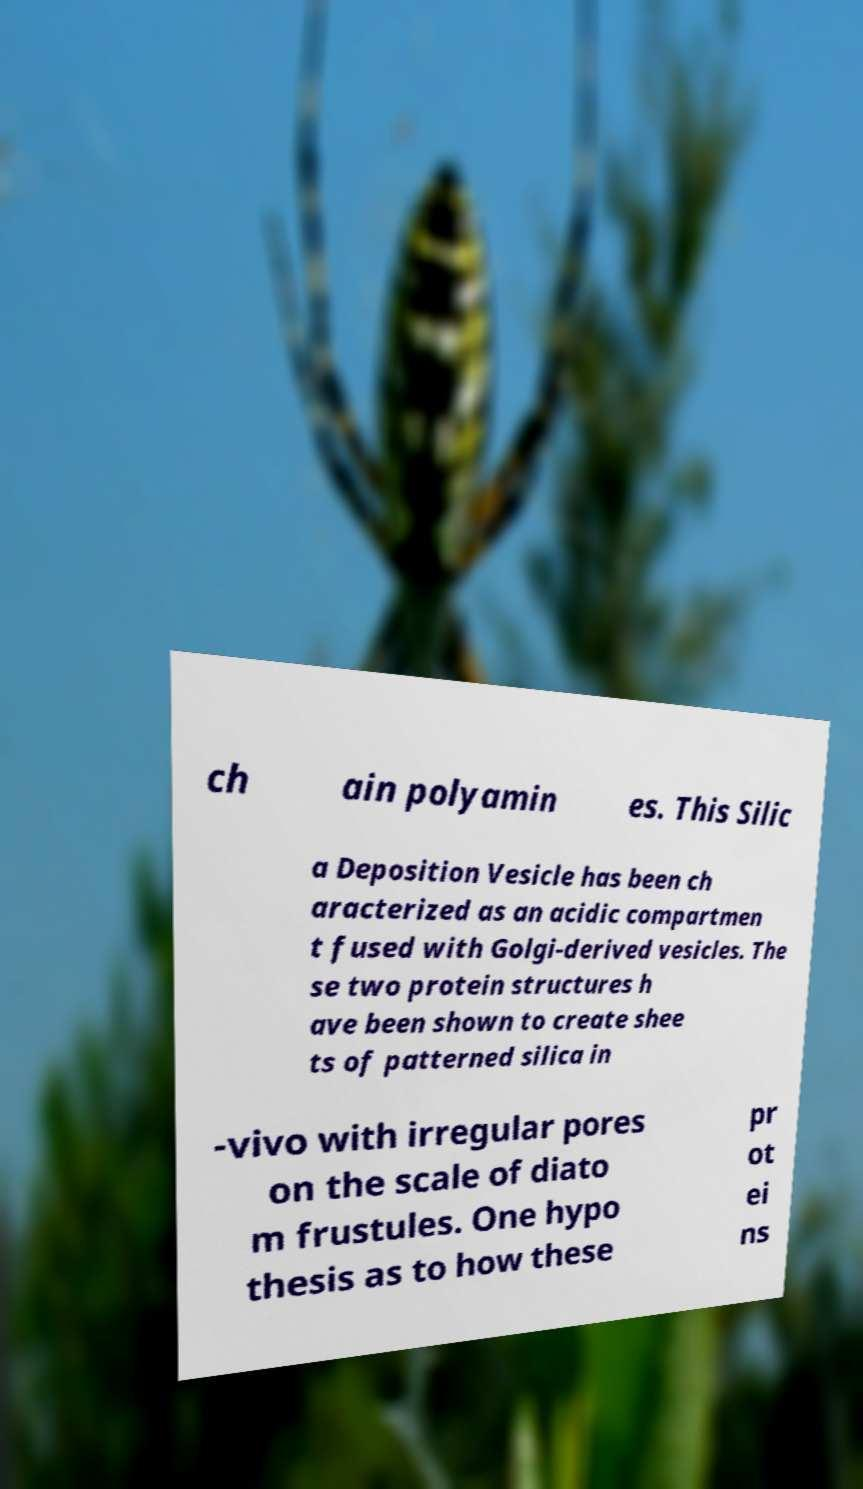Please identify and transcribe the text found in this image. ch ain polyamin es. This Silic a Deposition Vesicle has been ch aracterized as an acidic compartmen t fused with Golgi-derived vesicles. The se two protein structures h ave been shown to create shee ts of patterned silica in -vivo with irregular pores on the scale of diato m frustules. One hypo thesis as to how these pr ot ei ns 